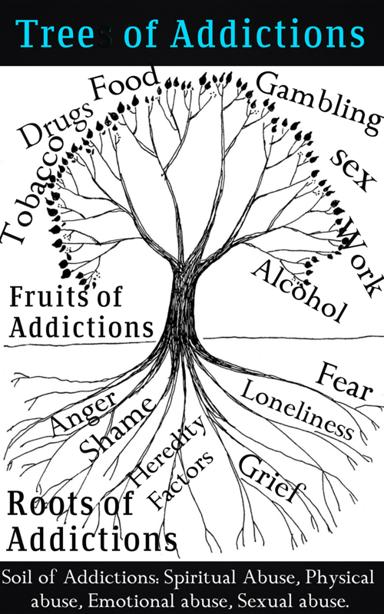How can the metaphor of the Tree of Addictions help individuals struggling with addiction? By looking at the Tree of Addictions, individuals grappling with their own addictive behaviors can gain a multifaceted understanding of their struggles. This metaphor is useful as a therapeutic tool, guiding them to recognize not only the addiction itself but the broader context of their actions. It suggests that healing is possible by addressing the deep roots and nurturing the soil with positive experiences and support. Awareness of this interconnected structure can foster insight, compassion, and a roadmap for recovery, potentially leading to more effective and sustainable healing processes. 